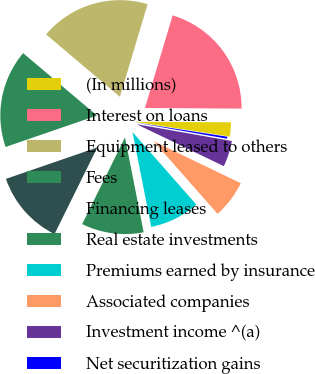<chart> <loc_0><loc_0><loc_500><loc_500><pie_chart><fcel>(In millions)<fcel>Interest on loans<fcel>Equipment leased to others<fcel>Fees<fcel>Financing leases<fcel>Real estate investments<fcel>Premiums earned by insurance<fcel>Associated companies<fcel>Investment income ^(a)<fcel>Net securitization gains<nl><fcel>2.35%<fcel>20.47%<fcel>18.46%<fcel>16.44%<fcel>12.42%<fcel>10.4%<fcel>8.39%<fcel>6.38%<fcel>4.36%<fcel>0.33%<nl></chart> 